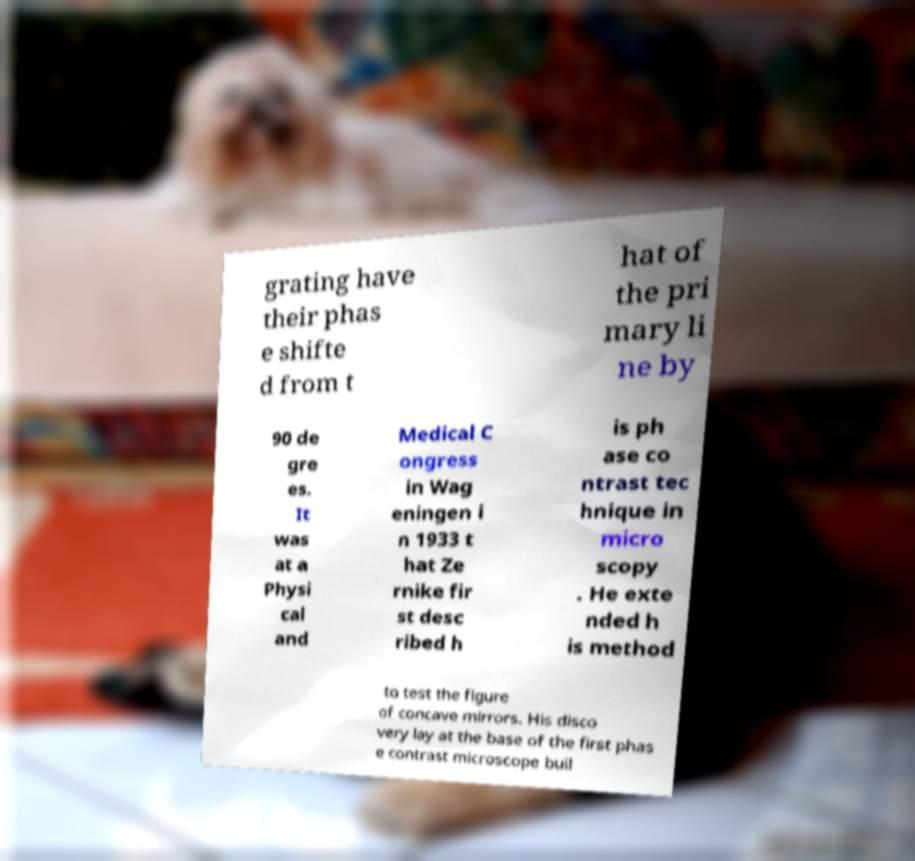Could you assist in decoding the text presented in this image and type it out clearly? grating have their phas e shifte d from t hat of the pri mary li ne by 90 de gre es. It was at a Physi cal and Medical C ongress in Wag eningen i n 1933 t hat Ze rnike fir st desc ribed h is ph ase co ntrast tec hnique in micro scopy . He exte nded h is method to test the figure of concave mirrors. His disco very lay at the base of the first phas e contrast microscope buil 